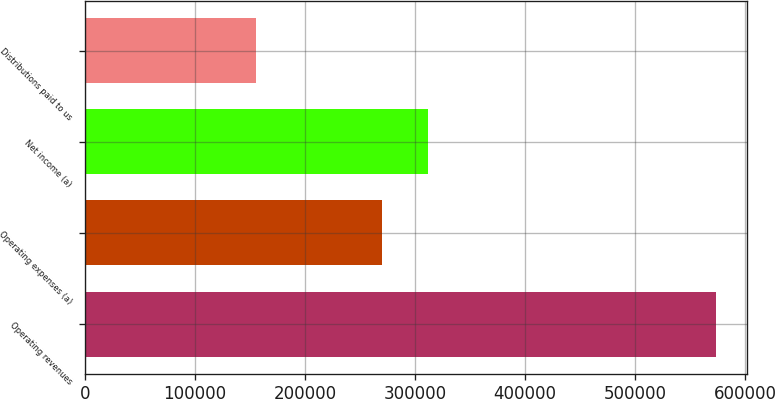Convert chart to OTSL. <chart><loc_0><loc_0><loc_500><loc_500><bar_chart><fcel>Operating revenues<fcel>Operating expenses (a)<fcel>Net income (a)<fcel>Distributions paid to us<nl><fcel>573197<fcel>269858<fcel>311604<fcel>155741<nl></chart> 